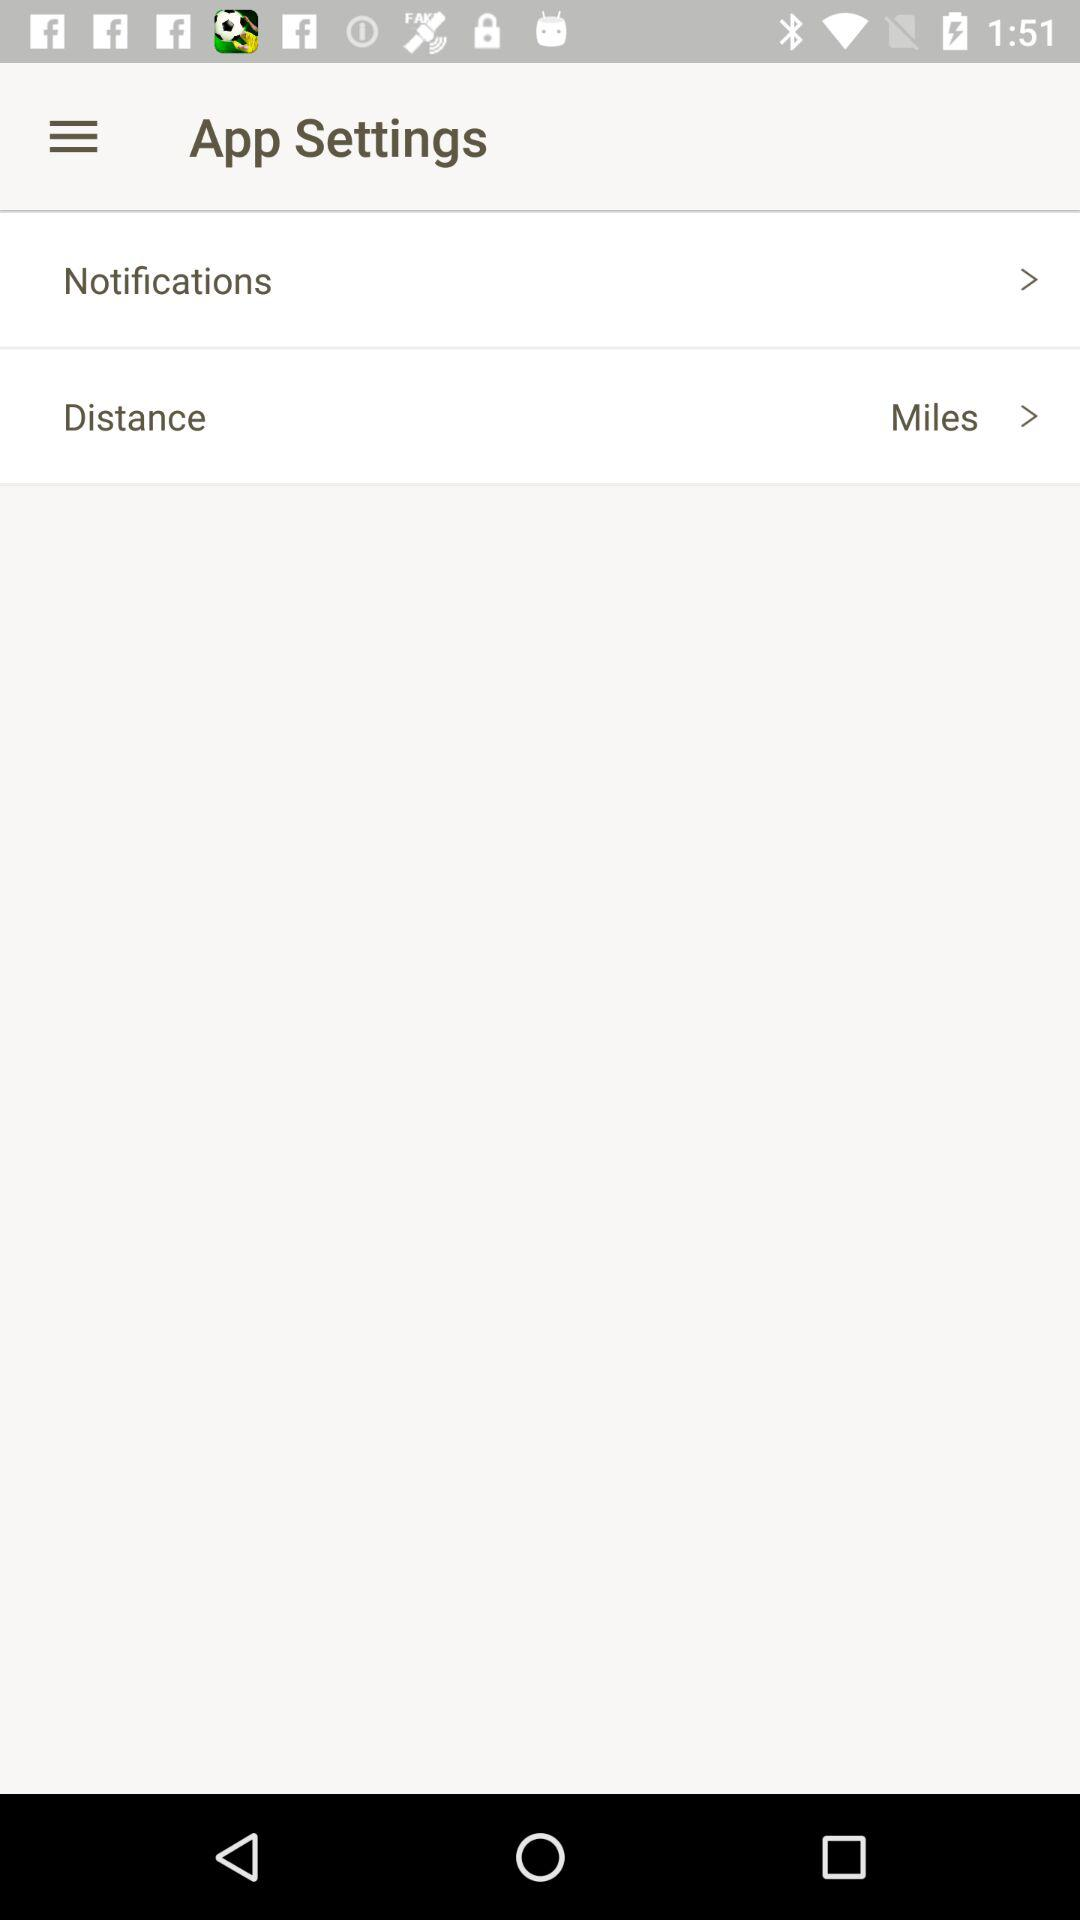What is the unit set for distance? The unit set for the distance is miles. 